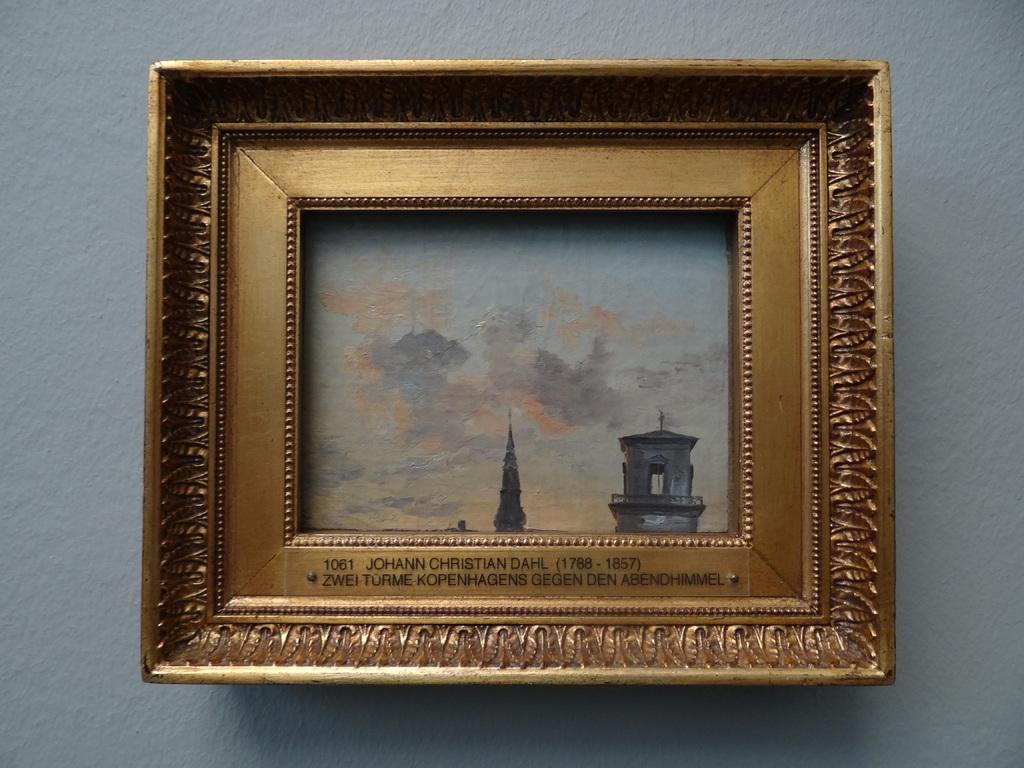<image>
Create a compact narrative representing the image presented. An intricate frame that says Johann Christian Dahl on it. 